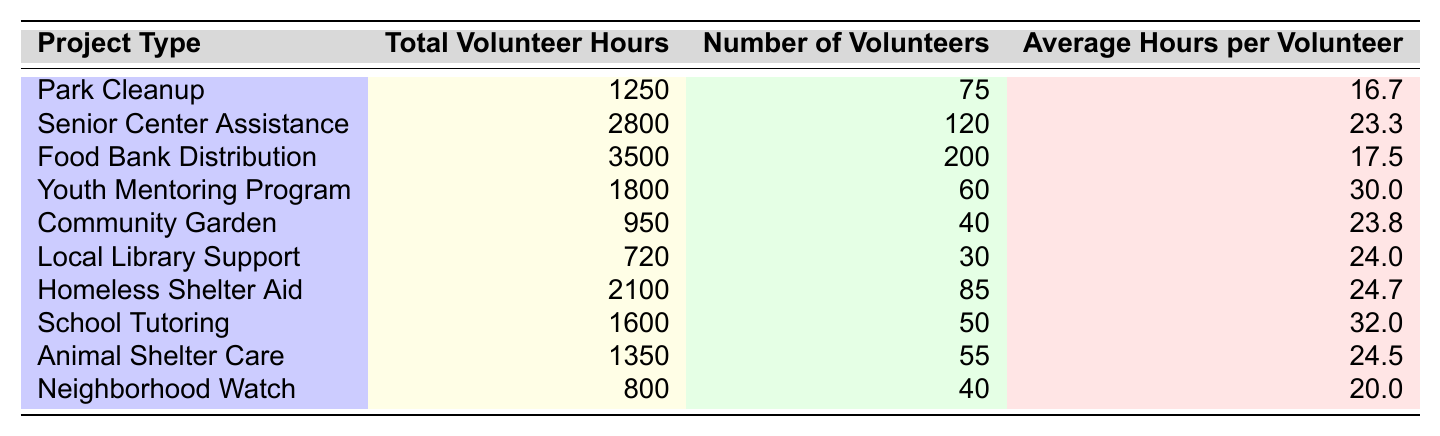What is the total volunteer hours for the Food Bank Distribution project? The table shows that for the Food Bank Distribution project, the total volunteer hours listed is 3,500.
Answer: 3,500 How many volunteers participated in the Senior Center Assistance project? According to the table, the number of volunteers for the Senior Center Assistance project is 120.
Answer: 120 What is the average number of hours volunteered per person in the Youth Mentoring Program? The table states that the average hours per volunteer in the Youth Mentoring Program is 30.0.
Answer: 30.0 Which project type had the highest number of total volunteer hours? By comparing the total volunteer hours in the table, it's clear that Food Bank Distribution has the highest at 3,500 hours.
Answer: Food Bank Distribution What is the difference in total volunteer hours between the Animal Shelter Care and Neighborhood Watch projects? The total volunteer hours for Animal Shelter Care is 1,350, and for Neighborhood Watch, it is 800. The difference is 1,350 - 800 = 550 hours.
Answer: 550 What is the total volunteer hours for all projects combined? Summing up the total volunteer hours from each project: 1250 + 2800 + 3500 + 1800 + 950 + 720 + 2100 + 1600 + 1350 + 800 = 15,950 hours.
Answer: 15,950 Is the average hours per volunteer in the Local Library Support project greater than 24 hours? The table indicates that the average hours per volunteer in Local Library Support is 24.0, which is equal to 24. Therefore, the statement is false.
Answer: No Which project has the lowest average hours per volunteer? The table lists the average hours per volunteer for Park Cleanup as 16.7, which is the lowest compared to all listed projects.
Answer: Park Cleanup What percentage of total volunteer hours does the Homeless Shelter Aid project represent compared to the total hours for all projects? First, the total volunteer hours is 15,950. The Homeless Shelter Aid hours are 2,100. The percentage is (2100/15950) * 100 = 13.15%.
Answer: 13.15% What is the total number of volunteers across all projects? Adding up the number of volunteers from each project gives: 75 + 120 + 200 + 60 + 40 + 30 + 85 + 50 + 55 + 40 = 955 volunteers in total.
Answer: 955 